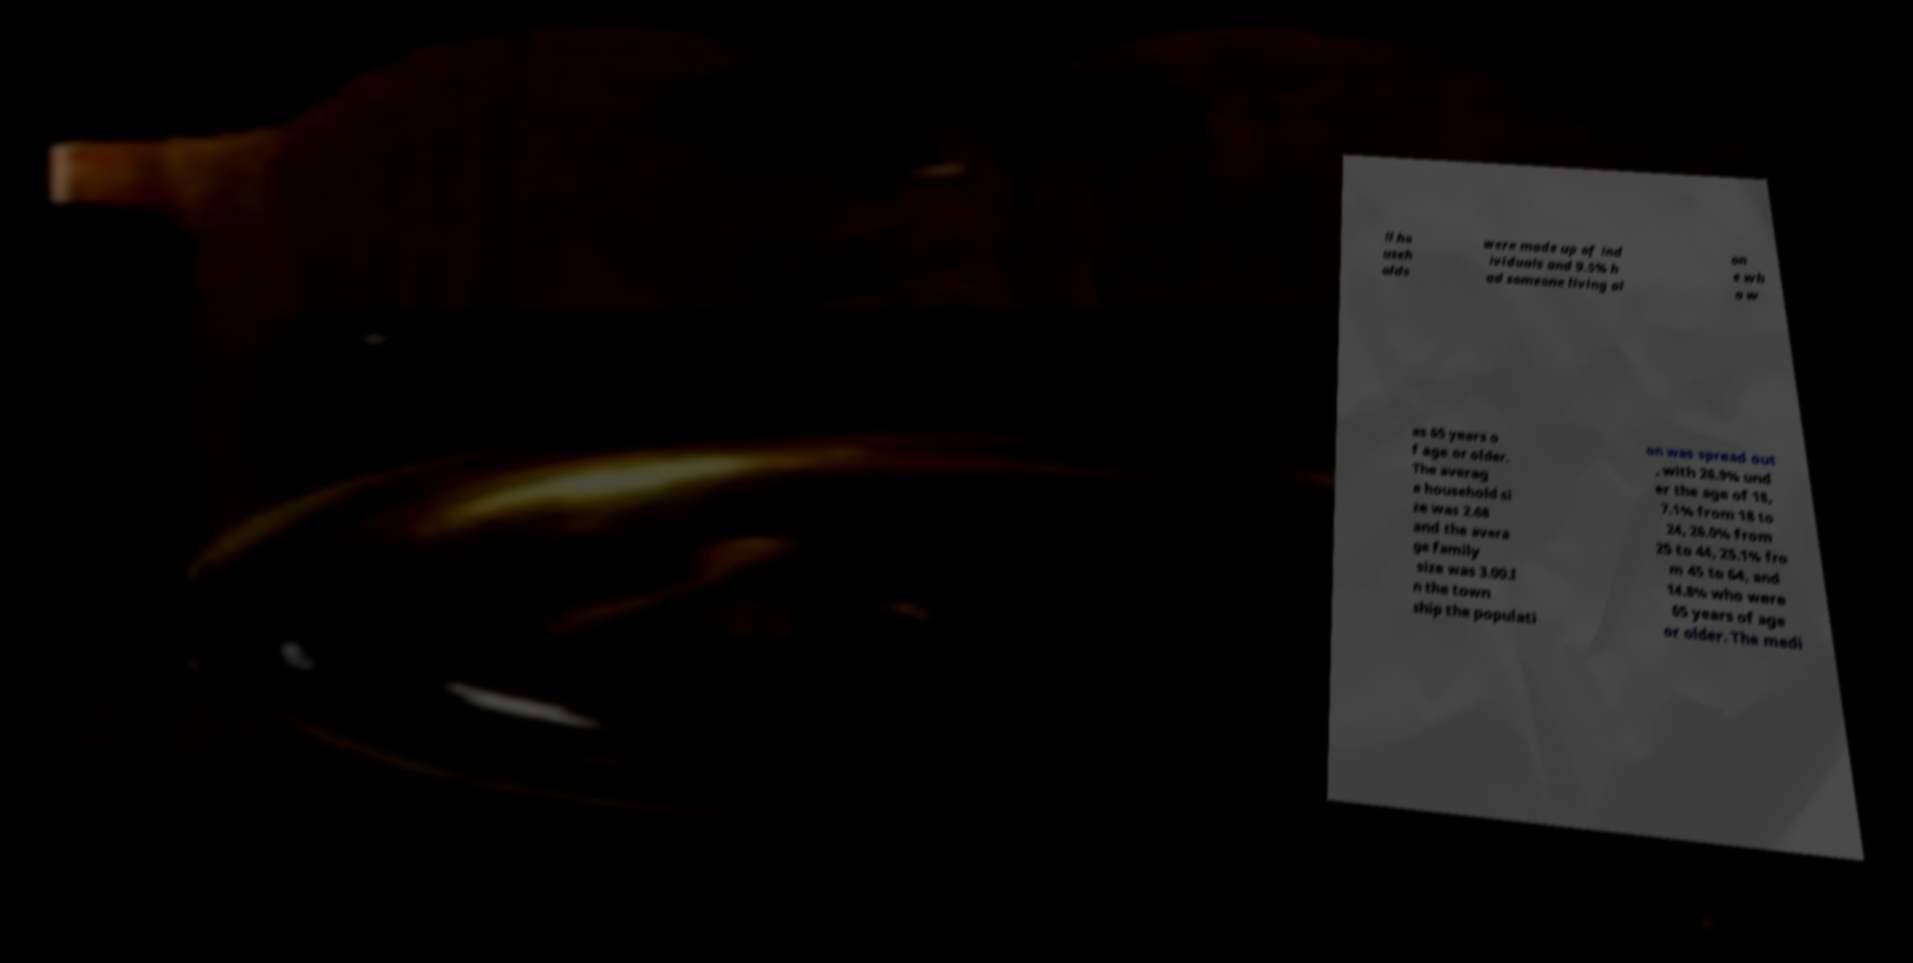There's text embedded in this image that I need extracted. Can you transcribe it verbatim? ll ho useh olds were made up of ind ividuals and 9.5% h ad someone living al on e wh o w as 65 years o f age or older. The averag e household si ze was 2.68 and the avera ge family size was 3.00.I n the town ship the populati on was spread out , with 26.9% und er the age of 18, 7.1% from 18 to 24, 26.0% from 25 to 44, 25.1% fro m 45 to 64, and 14.8% who were 65 years of age or older. The medi 